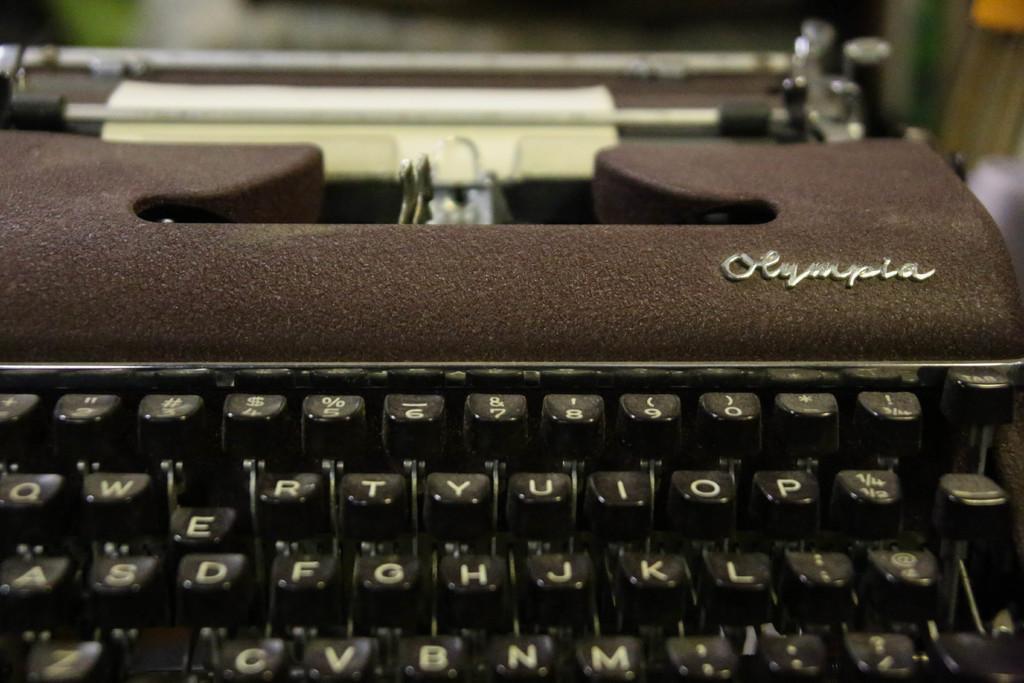What is the key on the far left?
Your answer should be very brief. Q. What brand of typewritter is this?
Make the answer very short. Olympia. 